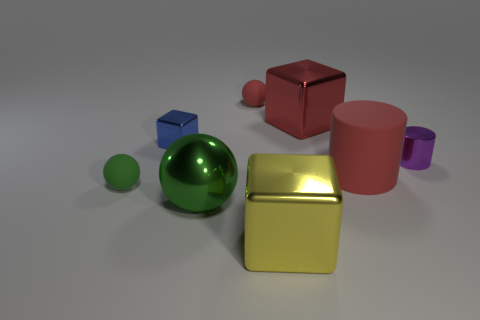Subtract all small balls. How many balls are left? 1 Subtract 1 cubes. How many cubes are left? 2 Add 2 small green metallic blocks. How many objects exist? 10 Subtract all spheres. How many objects are left? 5 Add 7 tiny rubber objects. How many tiny rubber objects are left? 9 Add 1 red shiny cylinders. How many red shiny cylinders exist? 1 Subtract 1 green balls. How many objects are left? 7 Subtract all small red matte spheres. Subtract all blue metallic things. How many objects are left? 6 